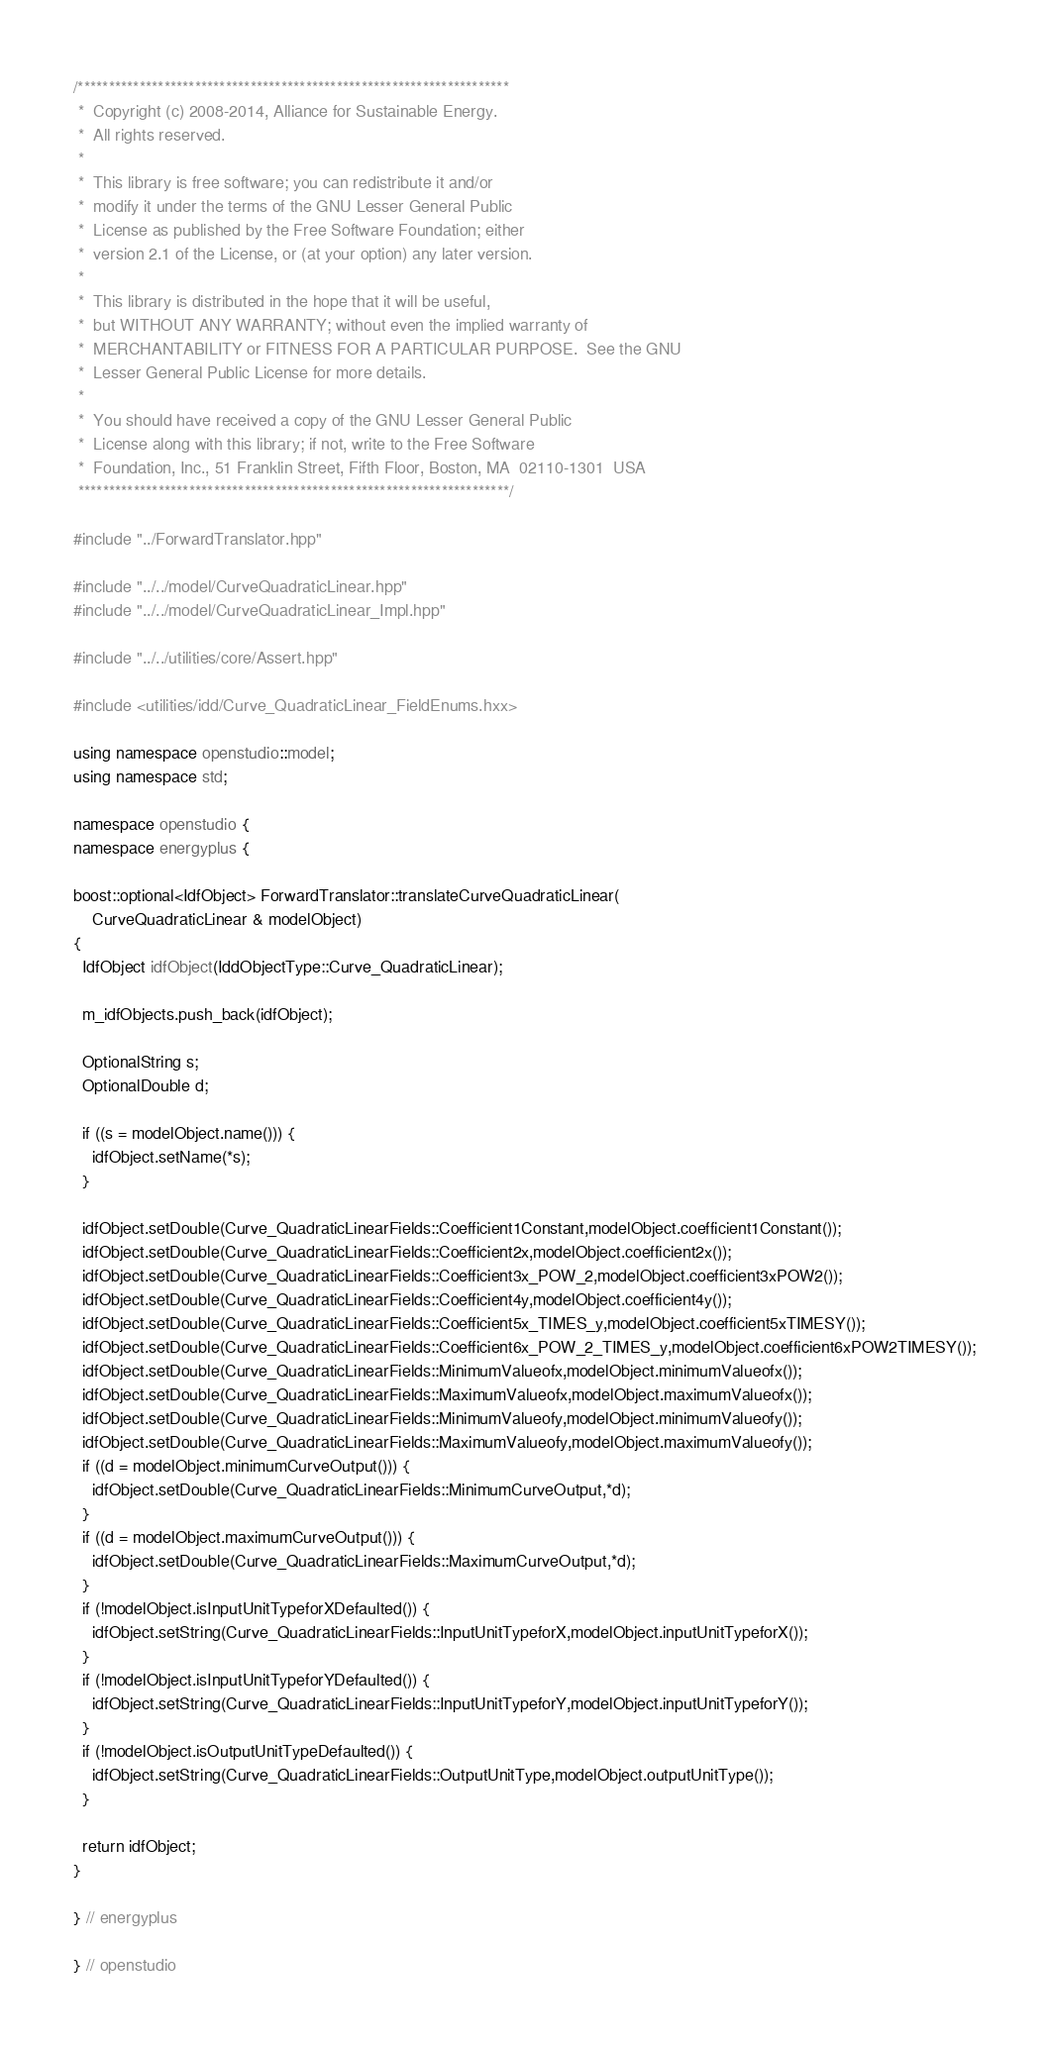<code> <loc_0><loc_0><loc_500><loc_500><_C++_>/**********************************************************************
 *  Copyright (c) 2008-2014, Alliance for Sustainable Energy.
 *  All rights reserved.
 *
 *  This library is free software; you can redistribute it and/or
 *  modify it under the terms of the GNU Lesser General Public
 *  License as published by the Free Software Foundation; either
 *  version 2.1 of the License, or (at your option) any later version.
 *
 *  This library is distributed in the hope that it will be useful,
 *  but WITHOUT ANY WARRANTY; without even the implied warranty of
 *  MERCHANTABILITY or FITNESS FOR A PARTICULAR PURPOSE.  See the GNU
 *  Lesser General Public License for more details.
 *
 *  You should have received a copy of the GNU Lesser General Public
 *  License along with this library; if not, write to the Free Software
 *  Foundation, Inc., 51 Franklin Street, Fifth Floor, Boston, MA  02110-1301  USA
 **********************************************************************/

#include "../ForwardTranslator.hpp"

#include "../../model/CurveQuadraticLinear.hpp"
#include "../../model/CurveQuadraticLinear_Impl.hpp"

#include "../../utilities/core/Assert.hpp"

#include <utilities/idd/Curve_QuadraticLinear_FieldEnums.hxx>

using namespace openstudio::model;
using namespace std;

namespace openstudio {
namespace energyplus {

boost::optional<IdfObject> ForwardTranslator::translateCurveQuadraticLinear( 
    CurveQuadraticLinear & modelObject)
{
  IdfObject idfObject(IddObjectType::Curve_QuadraticLinear);

  m_idfObjects.push_back(idfObject);

  OptionalString s;
  OptionalDouble d;

  if ((s = modelObject.name())) {
    idfObject.setName(*s);
  }

  idfObject.setDouble(Curve_QuadraticLinearFields::Coefficient1Constant,modelObject.coefficient1Constant());
  idfObject.setDouble(Curve_QuadraticLinearFields::Coefficient2x,modelObject.coefficient2x());
  idfObject.setDouble(Curve_QuadraticLinearFields::Coefficient3x_POW_2,modelObject.coefficient3xPOW2());
  idfObject.setDouble(Curve_QuadraticLinearFields::Coefficient4y,modelObject.coefficient4y());
  idfObject.setDouble(Curve_QuadraticLinearFields::Coefficient5x_TIMES_y,modelObject.coefficient5xTIMESY());
  idfObject.setDouble(Curve_QuadraticLinearFields::Coefficient6x_POW_2_TIMES_y,modelObject.coefficient6xPOW2TIMESY());
  idfObject.setDouble(Curve_QuadraticLinearFields::MinimumValueofx,modelObject.minimumValueofx());
  idfObject.setDouble(Curve_QuadraticLinearFields::MaximumValueofx,modelObject.maximumValueofx());
  idfObject.setDouble(Curve_QuadraticLinearFields::MinimumValueofy,modelObject.minimumValueofy());
  idfObject.setDouble(Curve_QuadraticLinearFields::MaximumValueofy,modelObject.maximumValueofy());
  if ((d = modelObject.minimumCurveOutput())) {
    idfObject.setDouble(Curve_QuadraticLinearFields::MinimumCurveOutput,*d);
  }
  if ((d = modelObject.maximumCurveOutput())) {
    idfObject.setDouble(Curve_QuadraticLinearFields::MaximumCurveOutput,*d);
  }
  if (!modelObject.isInputUnitTypeforXDefaulted()) {
    idfObject.setString(Curve_QuadraticLinearFields::InputUnitTypeforX,modelObject.inputUnitTypeforX());
  }
  if (!modelObject.isInputUnitTypeforYDefaulted()) {
    idfObject.setString(Curve_QuadraticLinearFields::InputUnitTypeforY,modelObject.inputUnitTypeforY());
  }
  if (!modelObject.isOutputUnitTypeDefaulted()) {
    idfObject.setString(Curve_QuadraticLinearFields::OutputUnitType,modelObject.outputUnitType());
  }

  return idfObject;
}

} // energyplus

} // openstudio

</code> 